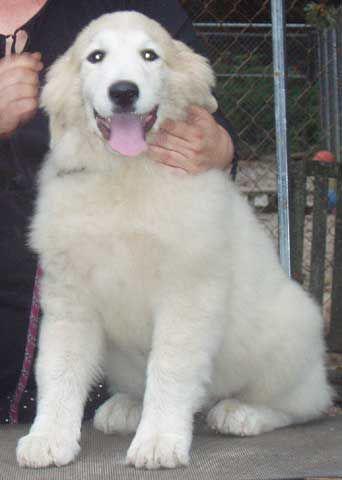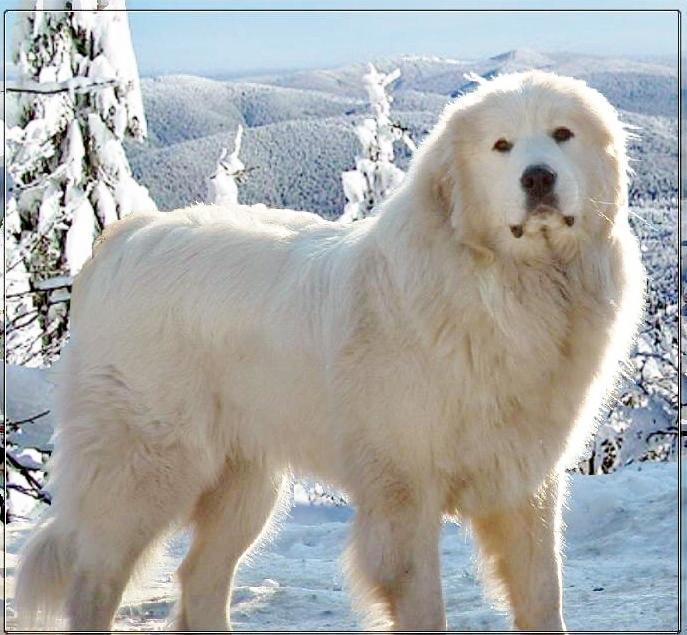The first image is the image on the left, the second image is the image on the right. Assess this claim about the two images: "In one image a dog is sitting down and in the other image the dog is standing.". Correct or not? Answer yes or no. Yes. The first image is the image on the left, the second image is the image on the right. For the images shown, is this caption "All of the white dogs are facing leftward, and one dog is posed on green grass." true? Answer yes or no. No. 